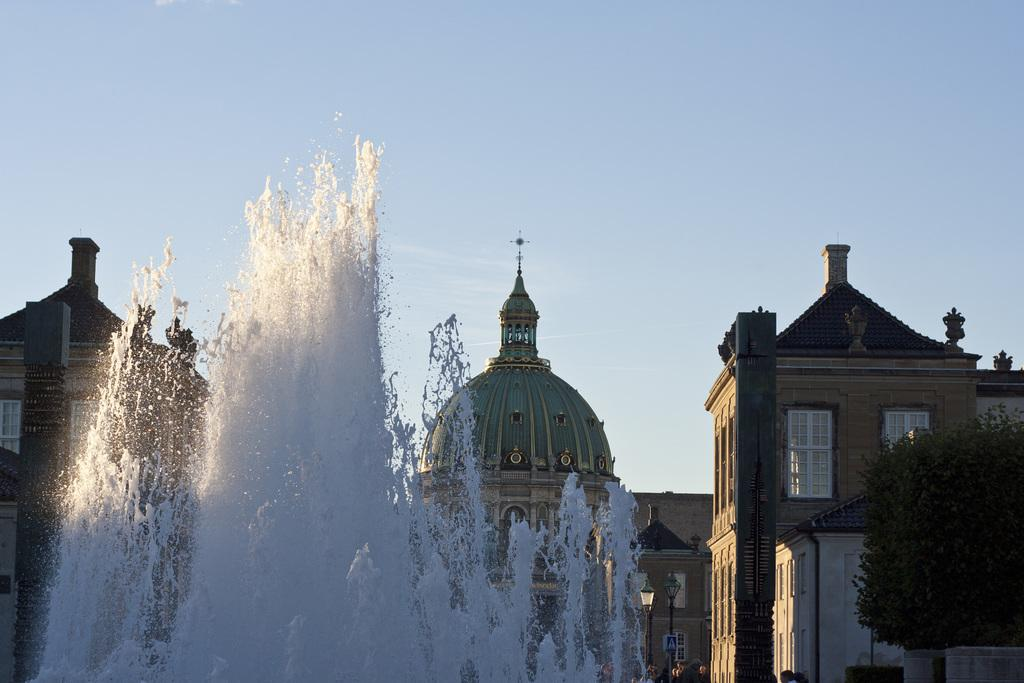What is the main feature in the image? There is a water fountain in the image. What type of natural element is present in the image? There is a tree in the image. What can be seen in the background of the image? There are buildings and poles in the background of the image. What are the boards attached to in the background of the image? The boards are attached to the poles in the background of the image. What part of the natural environment is visible in the image? The sky is visible in the background of the image. Where can the quartz be found in the image? There is no quartz present in the image. What type of fruit is hanging from the tree in the image? There is no fruit, including bananas, visible on the tree in the image. 